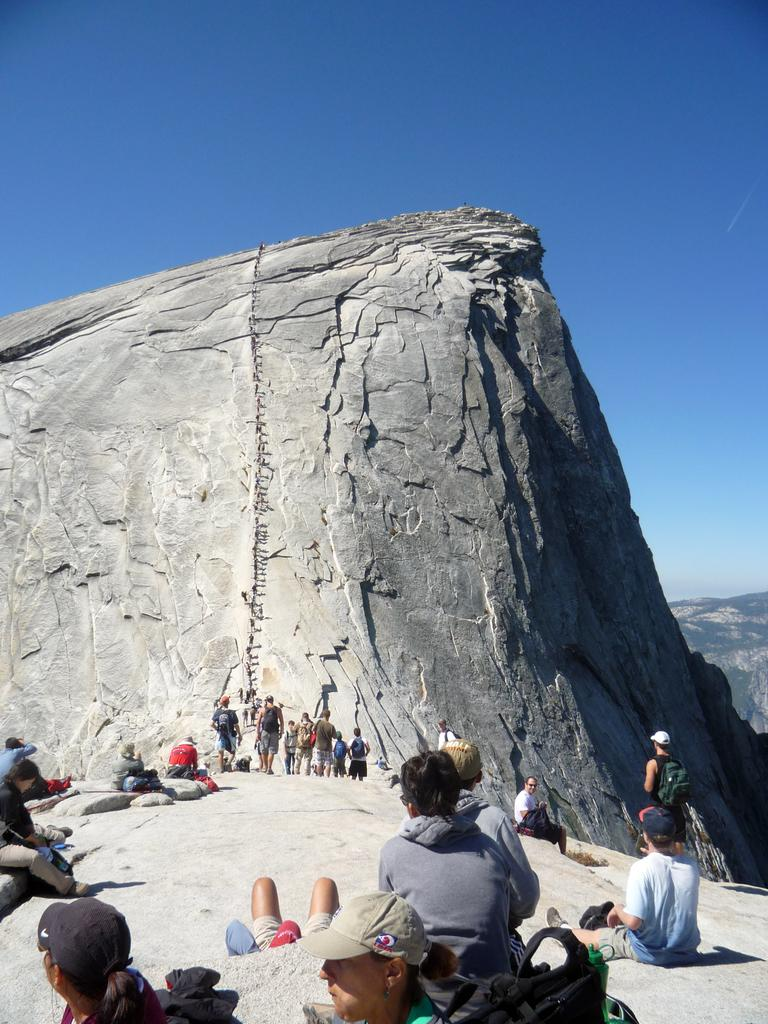What is the main subject of the image? There is a crowd in the image. What natural feature can be seen in the background? There are mountains in the image. What color is the sky in the image? The sky is blue in the image. What was the weather like when the image was taken? The image was taken during a sunny day. What type of grain is being harvested by the crowd in the image? There is no grain present in the image, and the crowd is not engaged in any harvesting activity. 